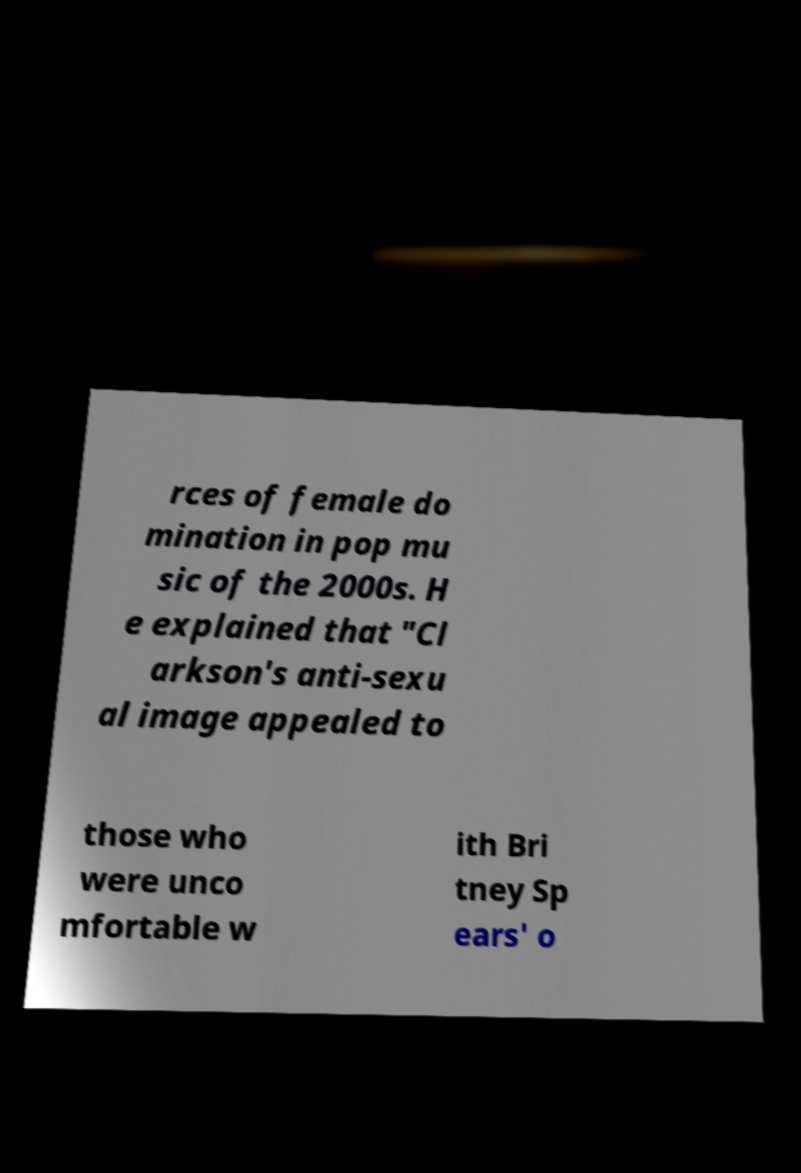What messages or text are displayed in this image? I need them in a readable, typed format. rces of female do mination in pop mu sic of the 2000s. H e explained that "Cl arkson's anti-sexu al image appealed to those who were unco mfortable w ith Bri tney Sp ears' o 